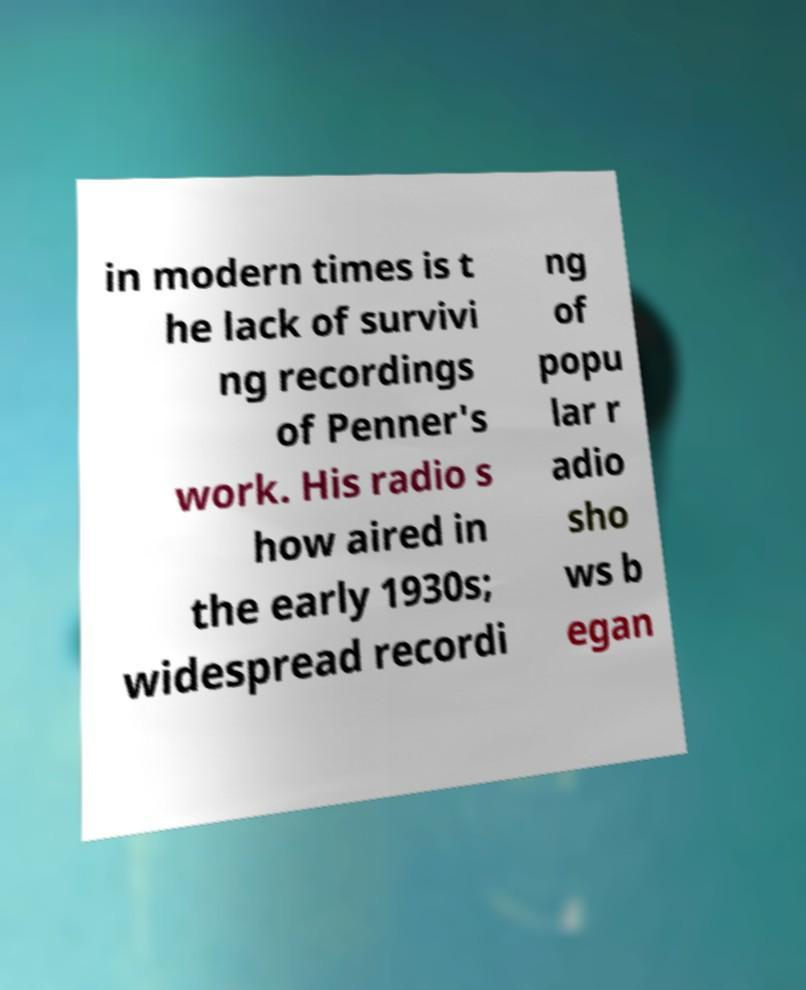Please identify and transcribe the text found in this image. in modern times is t he lack of survivi ng recordings of Penner's work. His radio s how aired in the early 1930s; widespread recordi ng of popu lar r adio sho ws b egan 